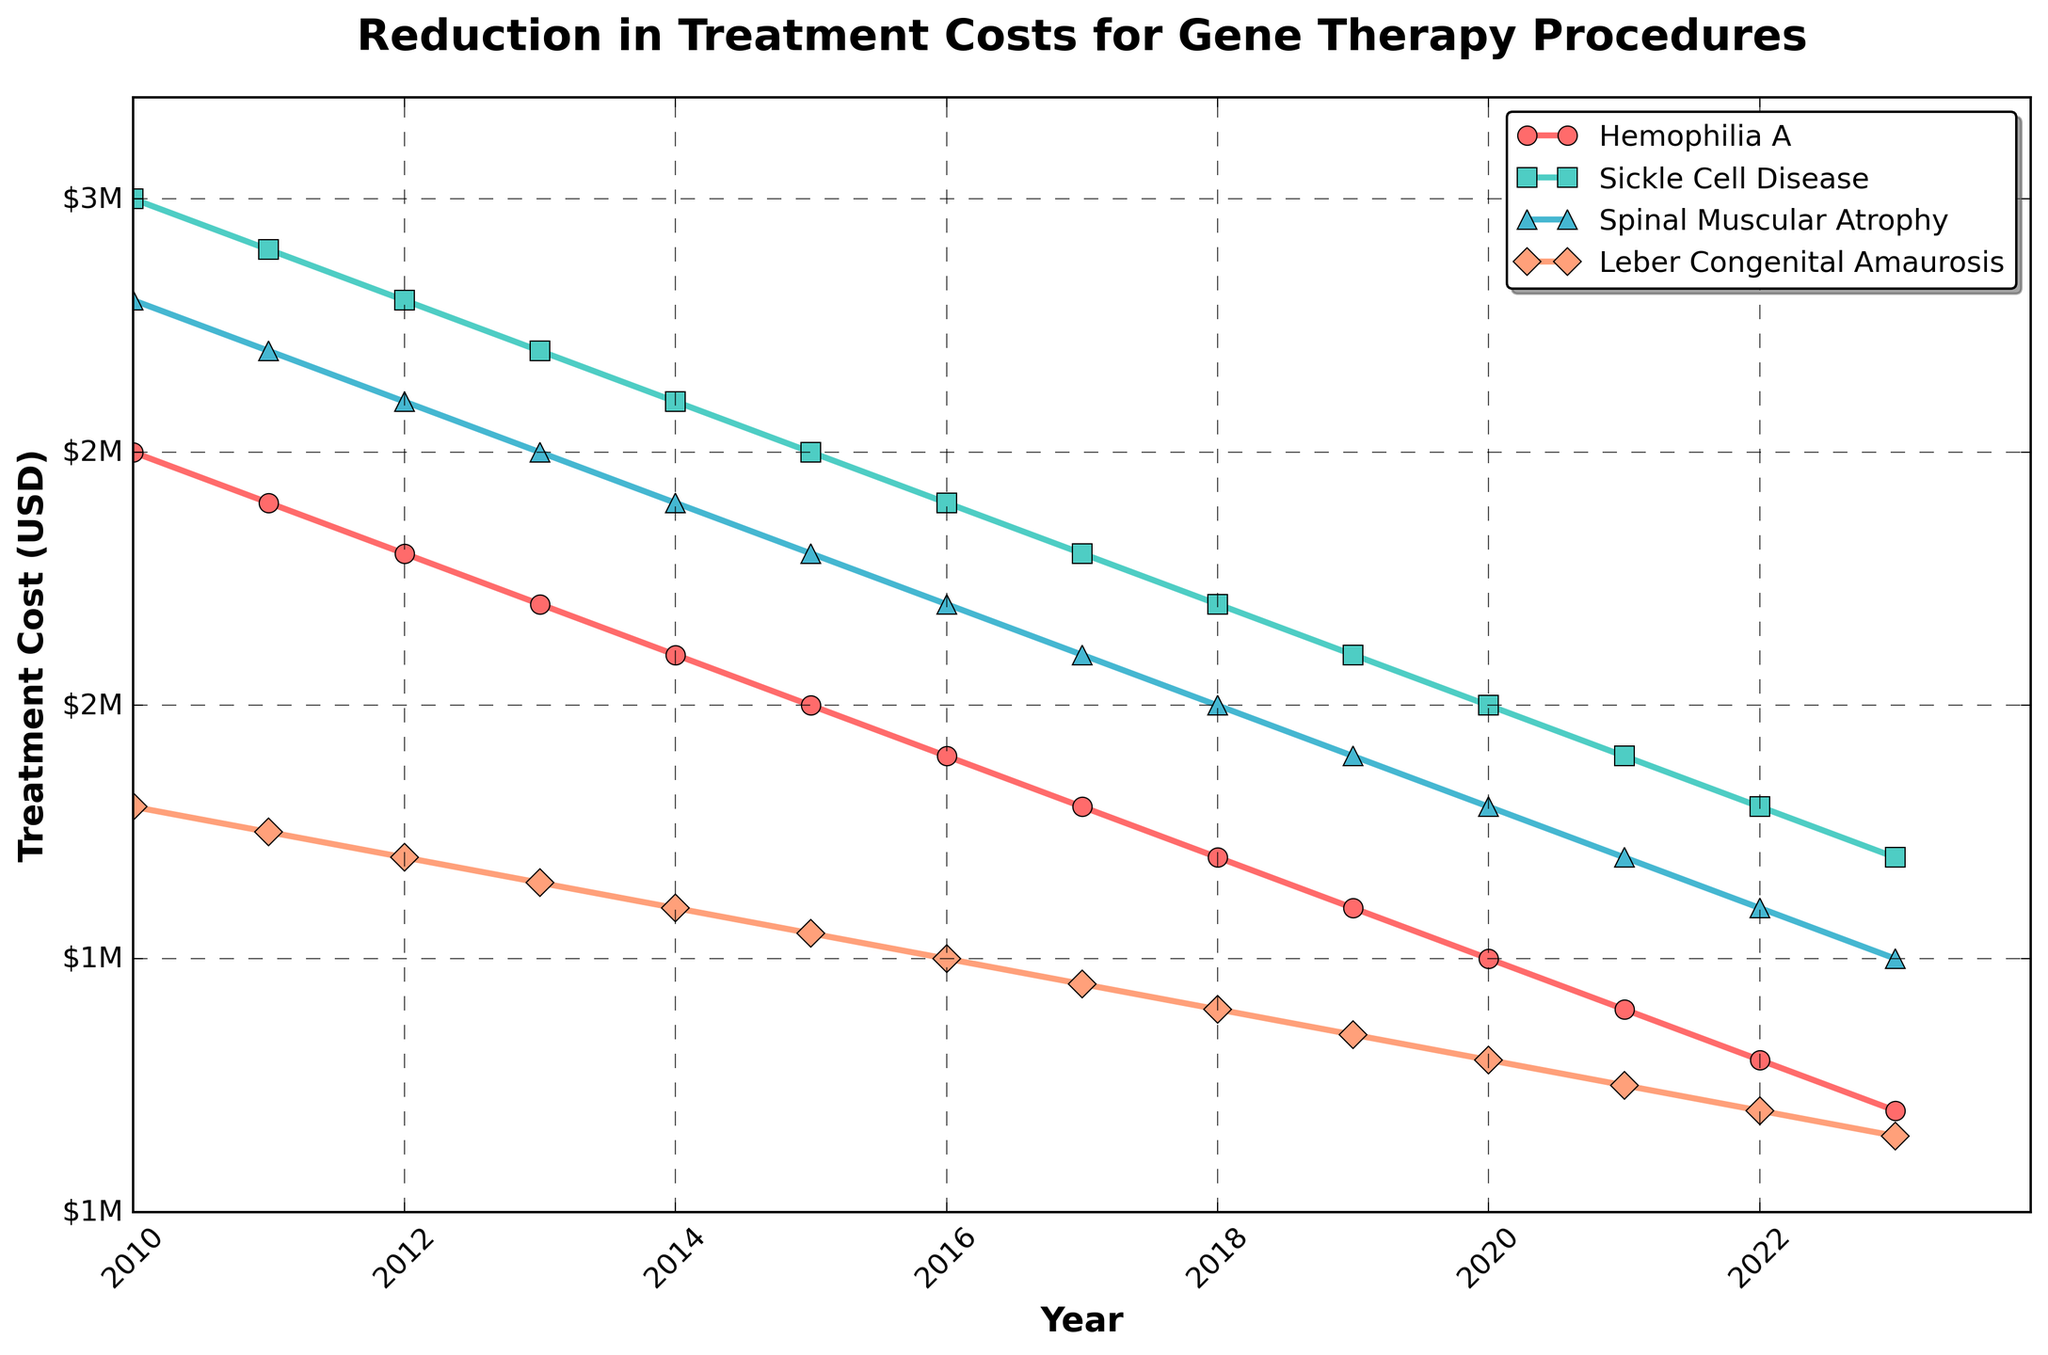Which genetic disorder has the greatest reduction in treatment costs from 2010 to 2023? To find the genetic disorder with the greatest reduction, calculate the difference between the 2010 and 2023 costs for each disorder. Hemophilia A: 2500000 - 1200000 = 1300000, Sickle Cell Disease: 3000000 - 1700000 = 1300000, Spinal Muscular Atrophy: 2800000 - 1500000 = 1300000, Leber Congenital Amaurosis: 1800000 - 1150000 = 650000. Hemophilia A, Sickle Cell Disease, and Spinal Muscular Atrophy all have the greatest reduction at 1300000.
Answer: Hemophilia A, Sickle Cell Disease, Spinal Muscular Atrophy How much did the treatment cost for Leber Congenital Amaurosis decrease from 2010 to 2023? Subtract the 2023 cost from the 2010 cost for Leber Congenital Amaurosis: 1800000 - 1150000 = 650000
Answer: 650000 In which year did the treatment cost for Hemophilia A first drop below 2000000? Look for the year in the Hemophilia A line where the cost first drops below 2000000: The cost drops to 1900000 in 2016.
Answer: 2016 Which disorder had the least amount of reduction in treatment cost from 2010 to 2023? Calculate the difference from 2010 to 2023 for each disorder. The disorder with the smallest difference is the one with the least reduction. Hemophilia A: 1300000, Sickle Cell Disease: 1300000, Spinal Muscular Atrophy: 1300000, Leber Congenital Amaurosis: 650000. Leber Congenital Amaurosis had the least reduction.
Answer: Leber Congenital Amaurosis What is the average reduction in treatment costs for all the disorders from 2010 to 2023? Calculate the total reduction for all disorders and then divide by 4. Hemophilia A: 1300000, Sickle Cell Disease: 1300000, Spinal Muscular Atrophy: 1300000, Leber Congenital Amaurosis: 650000. Total reduction = 1300000 + 1300000 + 1300000 + 650000 = 4550000. Average reduction = 4550000 / 4 = 1137500.
Answer: 1137500 Which disorder saw a consistent year-over-year decrease in treatment costs without any increase? Check each disorder's year-over-year values to identify which one consistently decreased each year. All listed disorders (Hemophilia A, Sickle Cell Disease, Spinal Muscular Atrophy, Leber Congenital Amaurosis) show a consistent year-over-year decrease.
Answer: All listed disorders In 2019, which disorder had the highest treatment cost? Compare the treatment costs in 2019 for each disorder. Hemophilia A: 1600000, Sickle Cell Disease: 2100000, Spinal Muscular Atrophy: 1900000, Leber Congenital Amaurosis: 1350000. Sickle Cell Disease had the highest cost in 2019.
Answer: Sickle Cell Disease By what percentage did the treatment cost for Sickle Cell Disease decrease from 2010 to 2023? Calculate the percentage decrease using the formula [(initial value - final value) / initial value] * 100. For Sickle Cell Disease: [(3000000 - 1700000) / 3000000] * 100 = (1300000 / 3000000) * 100 ≈ 43.33%.
Answer: 43.33% What is the difference in treatment costs between Sickle Cell Disease and Spinal Muscular Atrophy in 2020? Subtract the treatment cost of Spinal Muscular Atrophy from that of Sickle Cell Disease in 2020: 2000000 - 1800000 = 200000.
Answer: 200000 Is the reduction in treatment costs from 2010 to 2023 for Spinal Muscular Atrophy greater than the reduction for Leber Congenital Amaurosis? Calculate the reduction for each and compare. Spinal Muscular Atrophy: 2800000 - 1500000 = 1300000. Leber Congenital Amaurosis: 1800000 - 1150000 = 650000. The reduction for Spinal Muscular Atrophy (1300000) is greater than for Leber Congenital Amaurosis (650000).
Answer: Yes 